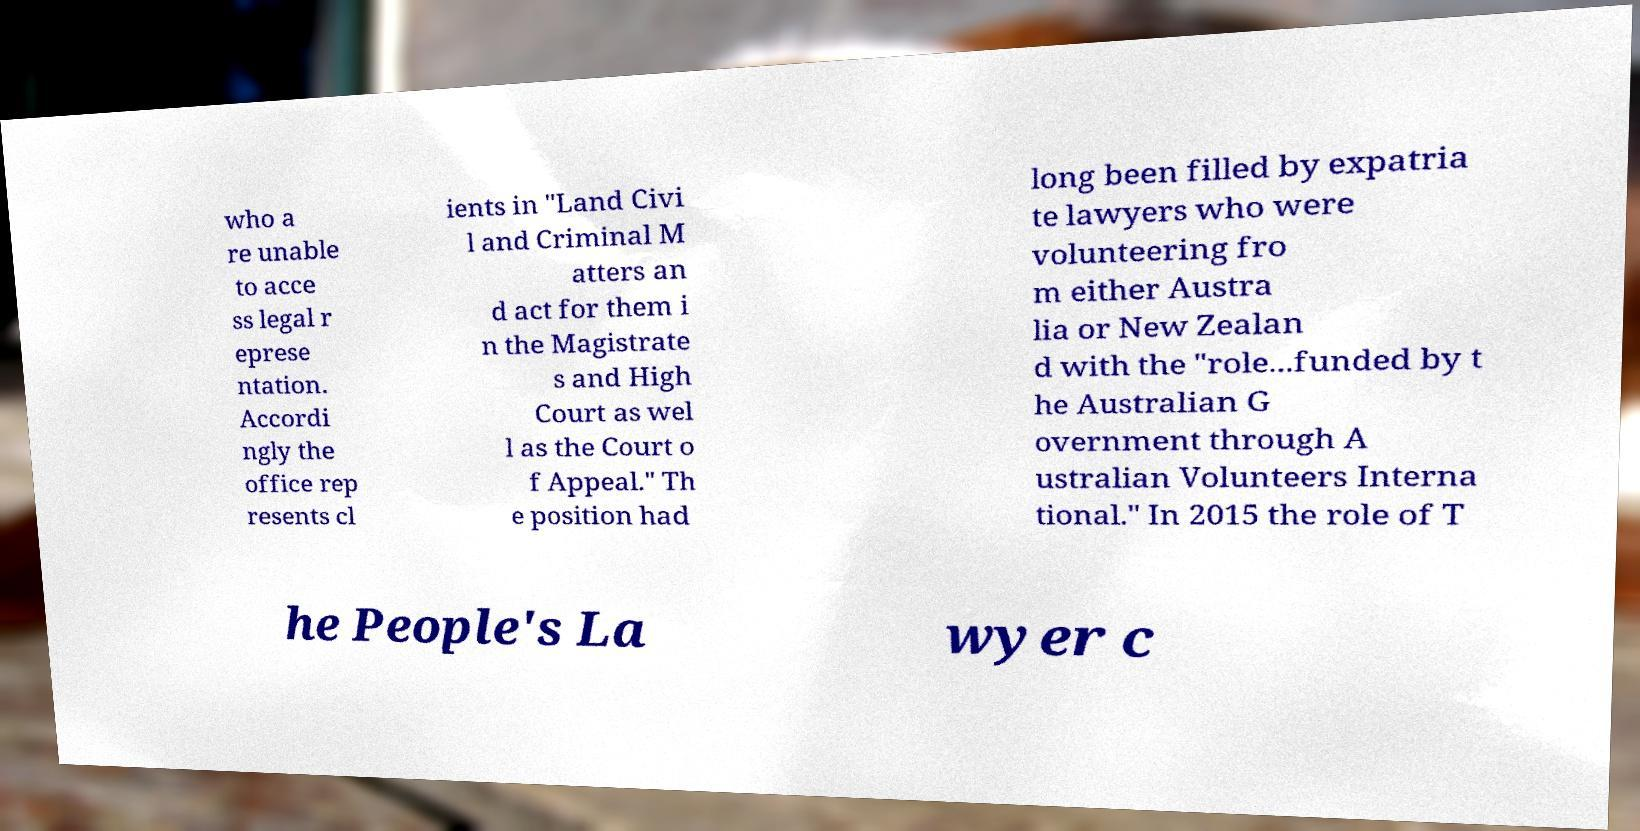For documentation purposes, I need the text within this image transcribed. Could you provide that? who a re unable to acce ss legal r eprese ntation. Accordi ngly the office rep resents cl ients in "Land Civi l and Criminal M atters an d act for them i n the Magistrate s and High Court as wel l as the Court o f Appeal." Th e position had long been filled by expatria te lawyers who were volunteering fro m either Austra lia or New Zealan d with the "role...funded by t he Australian G overnment through A ustralian Volunteers Interna tional." In 2015 the role of T he People's La wyer c 